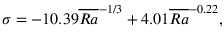Convert formula to latex. <formula><loc_0><loc_0><loc_500><loc_500>\sigma = - 1 0 . 3 9 \overline { R a } ^ { - 1 / 3 } + 4 . 0 1 \overline { R a } ^ { - 0 . 2 2 } ,</formula> 